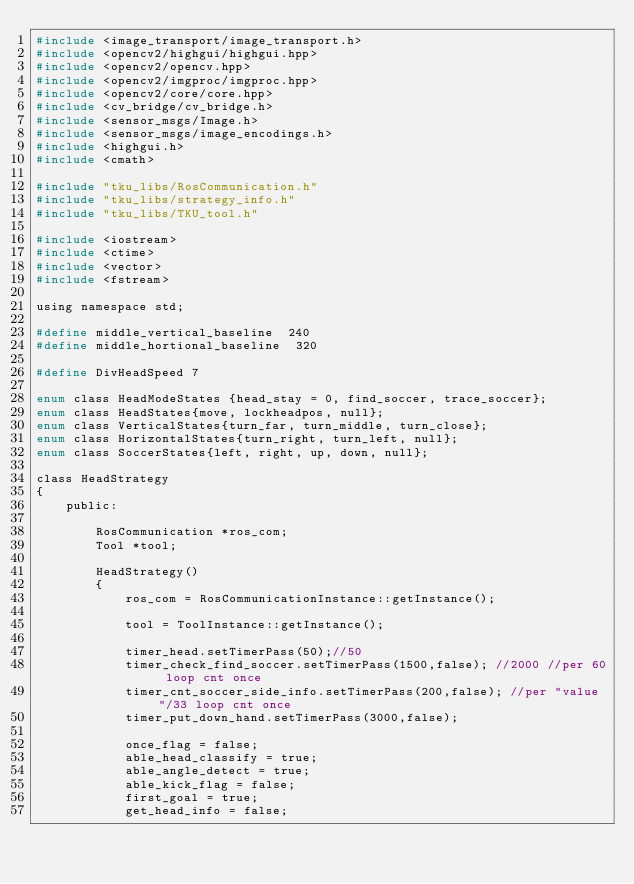<code> <loc_0><loc_0><loc_500><loc_500><_C_>#include <image_transport/image_transport.h>
#include <opencv2/highgui/highgui.hpp>
#include <opencv2/opencv.hpp>
#include <opencv2/imgproc/imgproc.hpp>
#include <opencv2/core/core.hpp>
#include <cv_bridge/cv_bridge.h>
#include <sensor_msgs/Image.h>
#include <sensor_msgs/image_encodings.h>
#include <highgui.h>
#include <cmath>

#include "tku_libs/RosCommunication.h"
#include "tku_libs/strategy_info.h"
#include "tku_libs/TKU_tool.h"

#include <iostream>
#include <ctime>
#include <vector>
#include <fstream>

using namespace std;

#define middle_vertical_baseline  240
#define	middle_hortional_baseline  320

#define DivHeadSpeed 7

enum class HeadModeStates {head_stay = 0, find_soccer, trace_soccer};
enum class HeadStates{move, lockheadpos, null};
enum class VerticalStates{turn_far, turn_middle, turn_close};
enum class HorizontalStates{turn_right, turn_left, null};
enum class SoccerStates{left, right, up, down, null};

class HeadStrategy
{
    public:

        RosCommunication *ros_com;
        Tool *tool;

        HeadStrategy()
	    {
            ros_com = RosCommunicationInstance::getInstance();

            tool = ToolInstance::getInstance();

            timer_head.setTimerPass(50);//50
            timer_check_find_soccer.setTimerPass(1500,false); //2000 //per 60 loop cnt once
            timer_cnt_soccer_side_info.setTimerPass(200,false); //per "value"/33 loop cnt once
            timer_put_down_hand.setTimerPass(3000,false);

            once_flag = false;
            able_head_classify = true;
            able_angle_detect = true;
            able_kick_flag = false;
            first_goal = true;
            get_head_info = false;</code> 